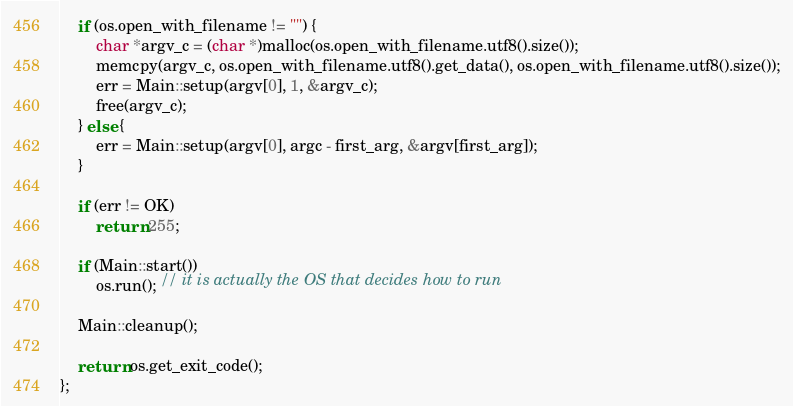Convert code to text. <code><loc_0><loc_0><loc_500><loc_500><_ObjectiveC_>	if (os.open_with_filename != "") {
		char *argv_c = (char *)malloc(os.open_with_filename.utf8().size());
		memcpy(argv_c, os.open_with_filename.utf8().get_data(), os.open_with_filename.utf8().size());
		err = Main::setup(argv[0], 1, &argv_c);
		free(argv_c);
	} else {
		err = Main::setup(argv[0], argc - first_arg, &argv[first_arg]);
	}

	if (err != OK)
		return 255;

	if (Main::start())
		os.run(); // it is actually the OS that decides how to run

	Main::cleanup();

	return os.get_exit_code();
};
</code> 